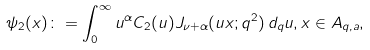<formula> <loc_0><loc_0><loc_500><loc_500>\psi _ { 2 } ( x ) \colon = \int _ { 0 } ^ { \infty } u ^ { \alpha } C _ { 2 } ( u ) J _ { \nu + \alpha } ( u x ; q ^ { 2 } ) \, d _ { q } u , x \in A _ { q , a } ,</formula> 